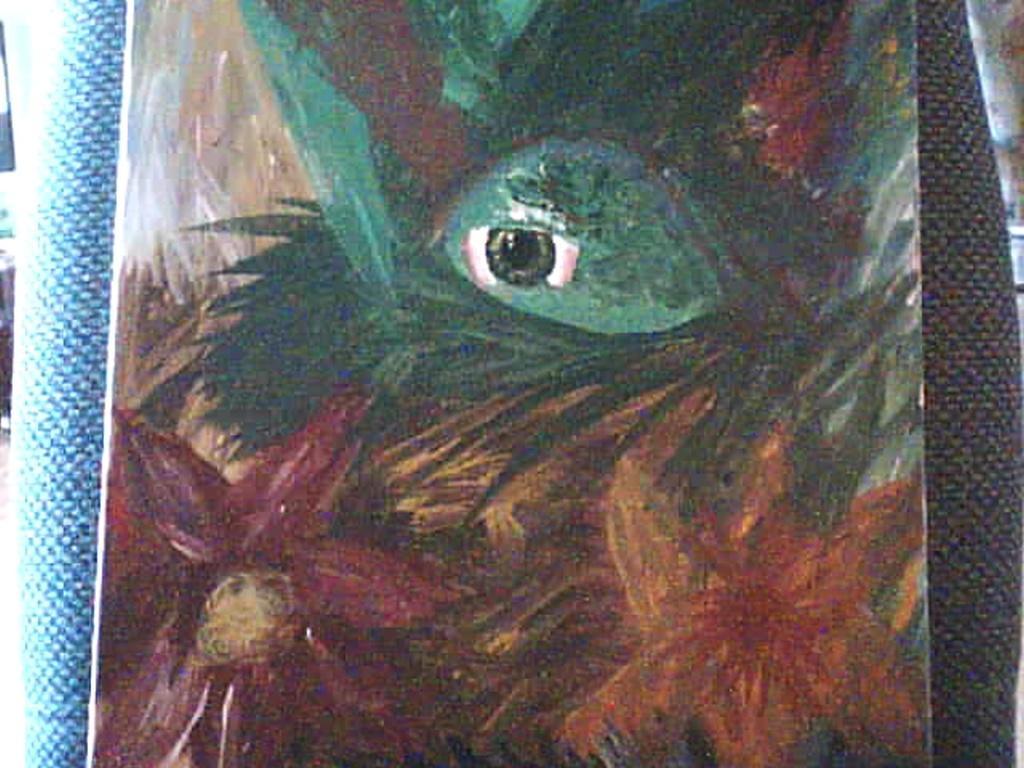In one or two sentences, can you explain what this image depicts? In this image in the front there is a painting. 